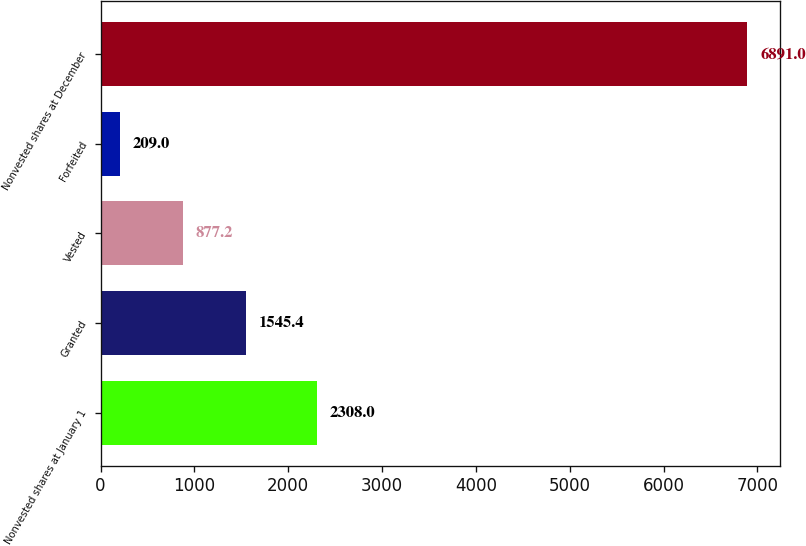Convert chart to OTSL. <chart><loc_0><loc_0><loc_500><loc_500><bar_chart><fcel>Nonvested shares at January 1<fcel>Granted<fcel>Vested<fcel>Forfeited<fcel>Nonvested shares at December<nl><fcel>2308<fcel>1545.4<fcel>877.2<fcel>209<fcel>6891<nl></chart> 